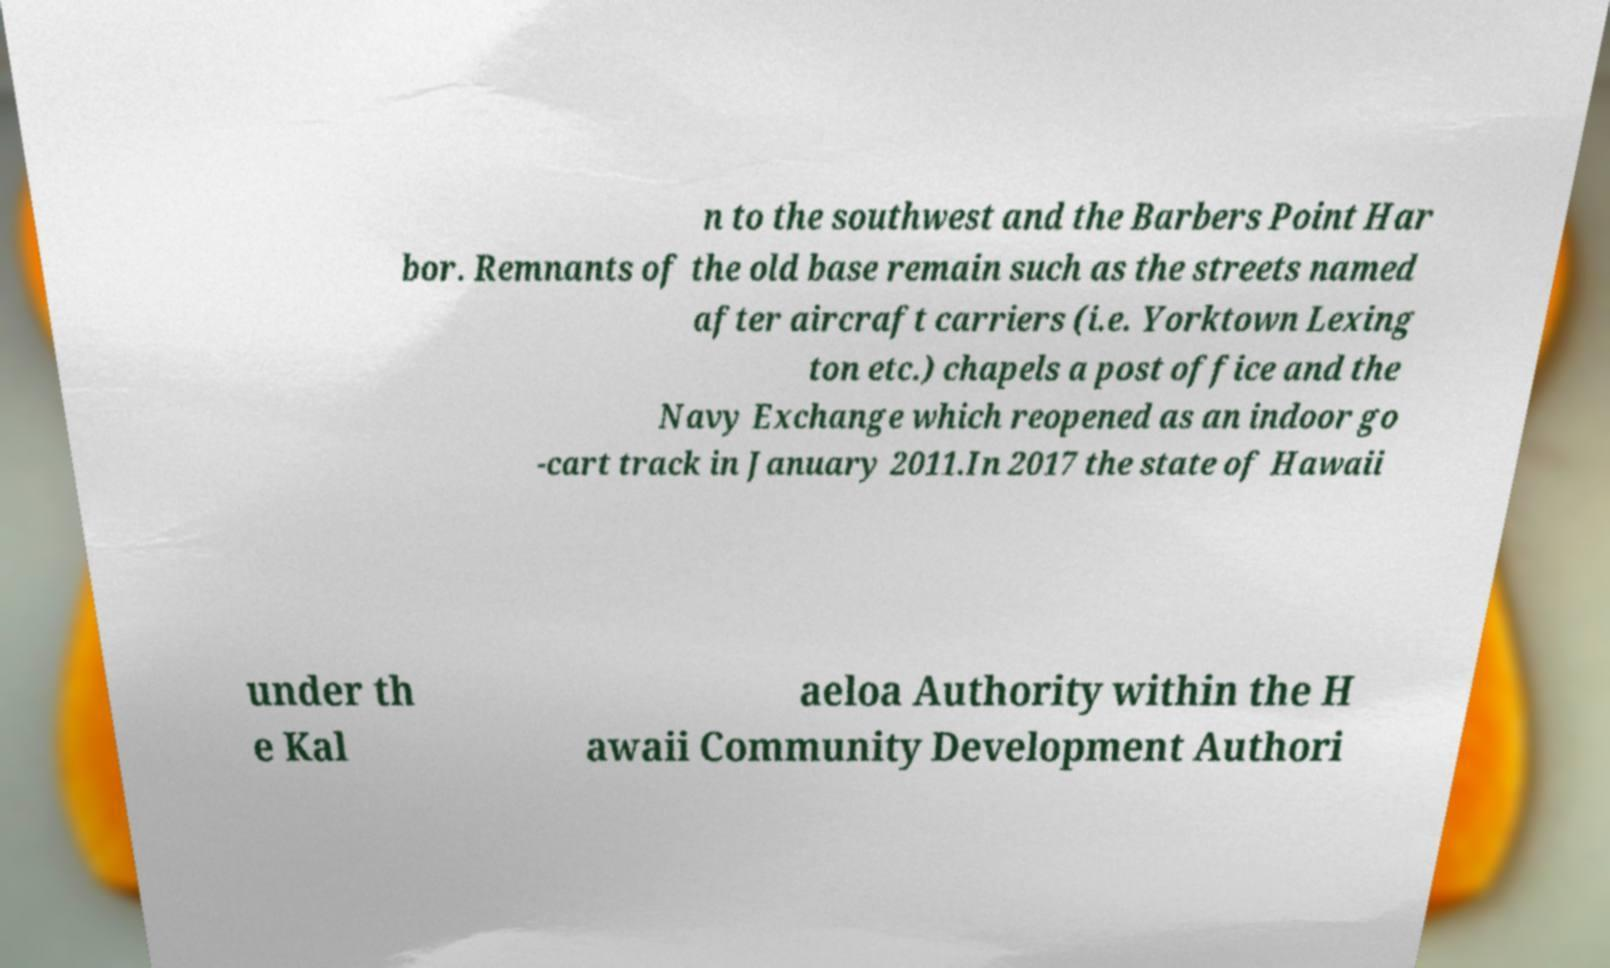There's text embedded in this image that I need extracted. Can you transcribe it verbatim? n to the southwest and the Barbers Point Har bor. Remnants of the old base remain such as the streets named after aircraft carriers (i.e. Yorktown Lexing ton etc.) chapels a post office and the Navy Exchange which reopened as an indoor go -cart track in January 2011.In 2017 the state of Hawaii under th e Kal aeloa Authority within the H awaii Community Development Authori 